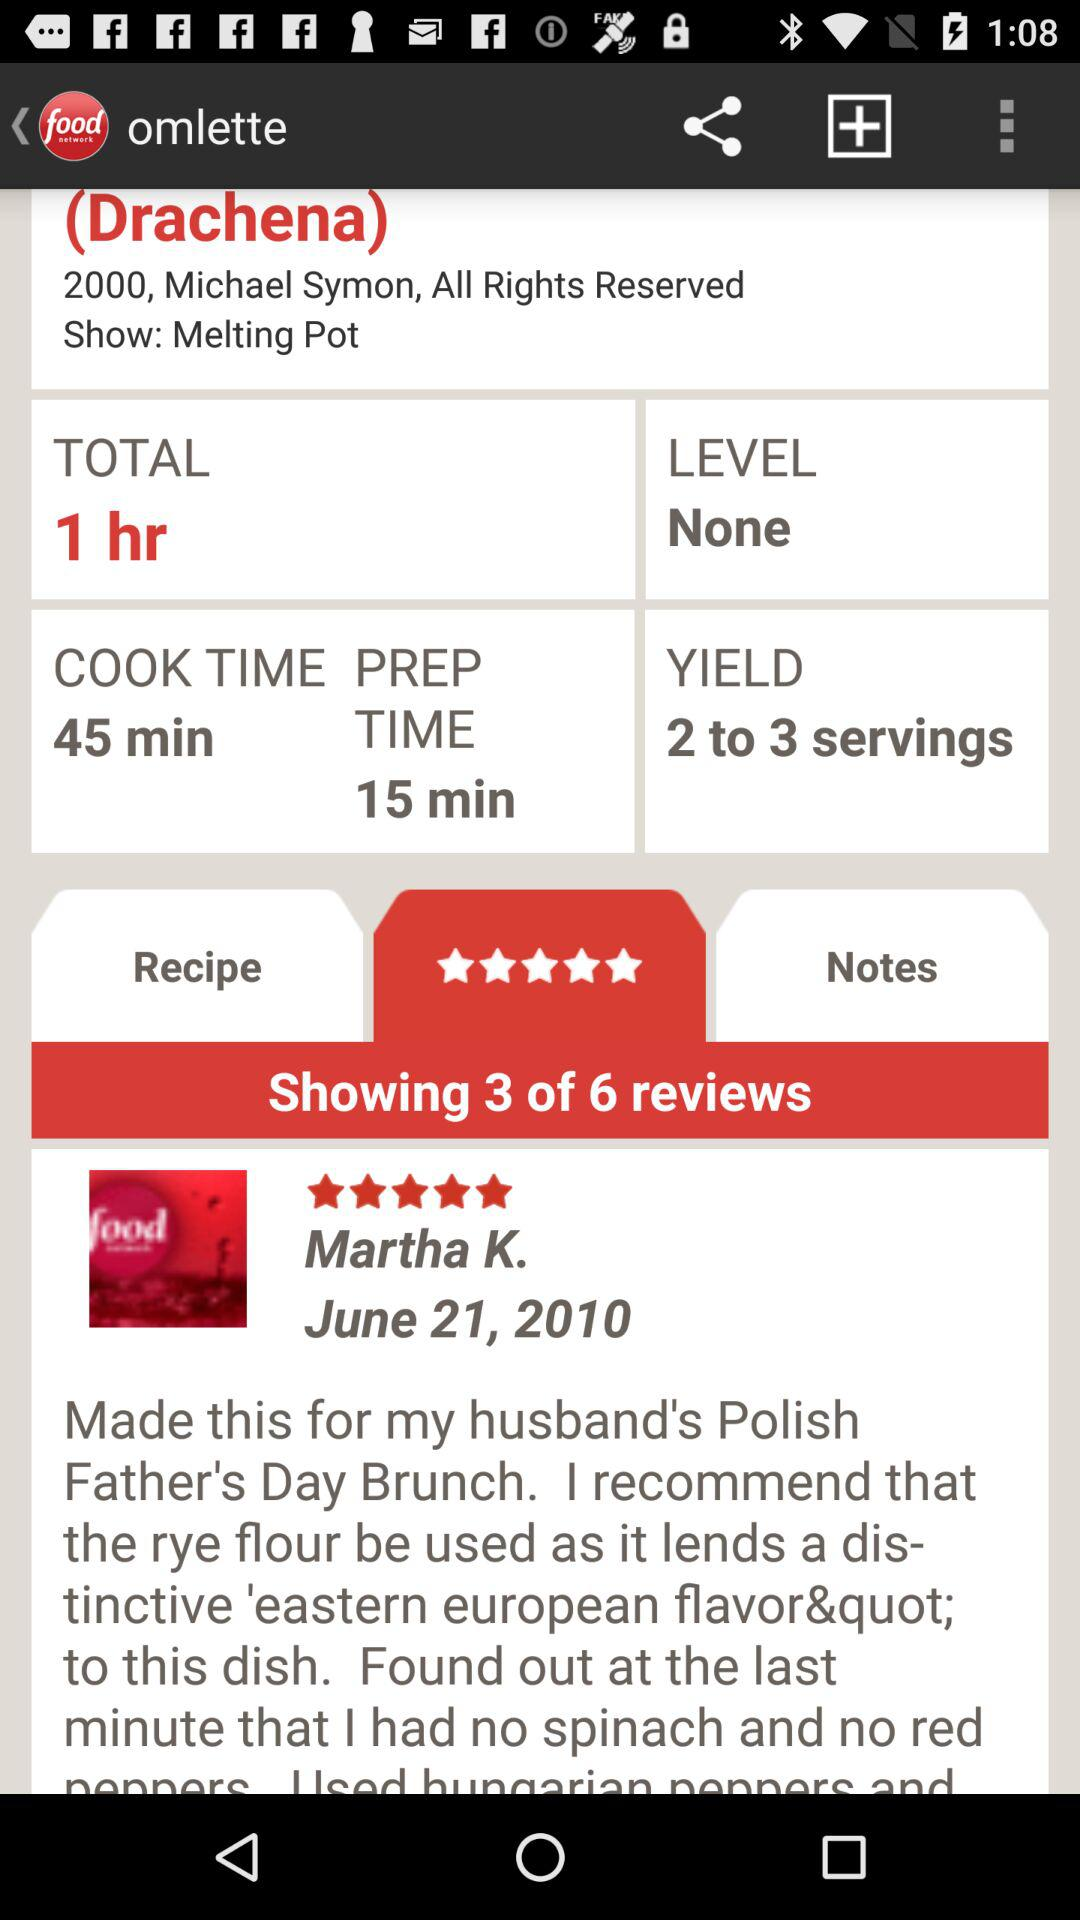What is the level mentioned there on the screen? The level mentioned there on the screen is none. 